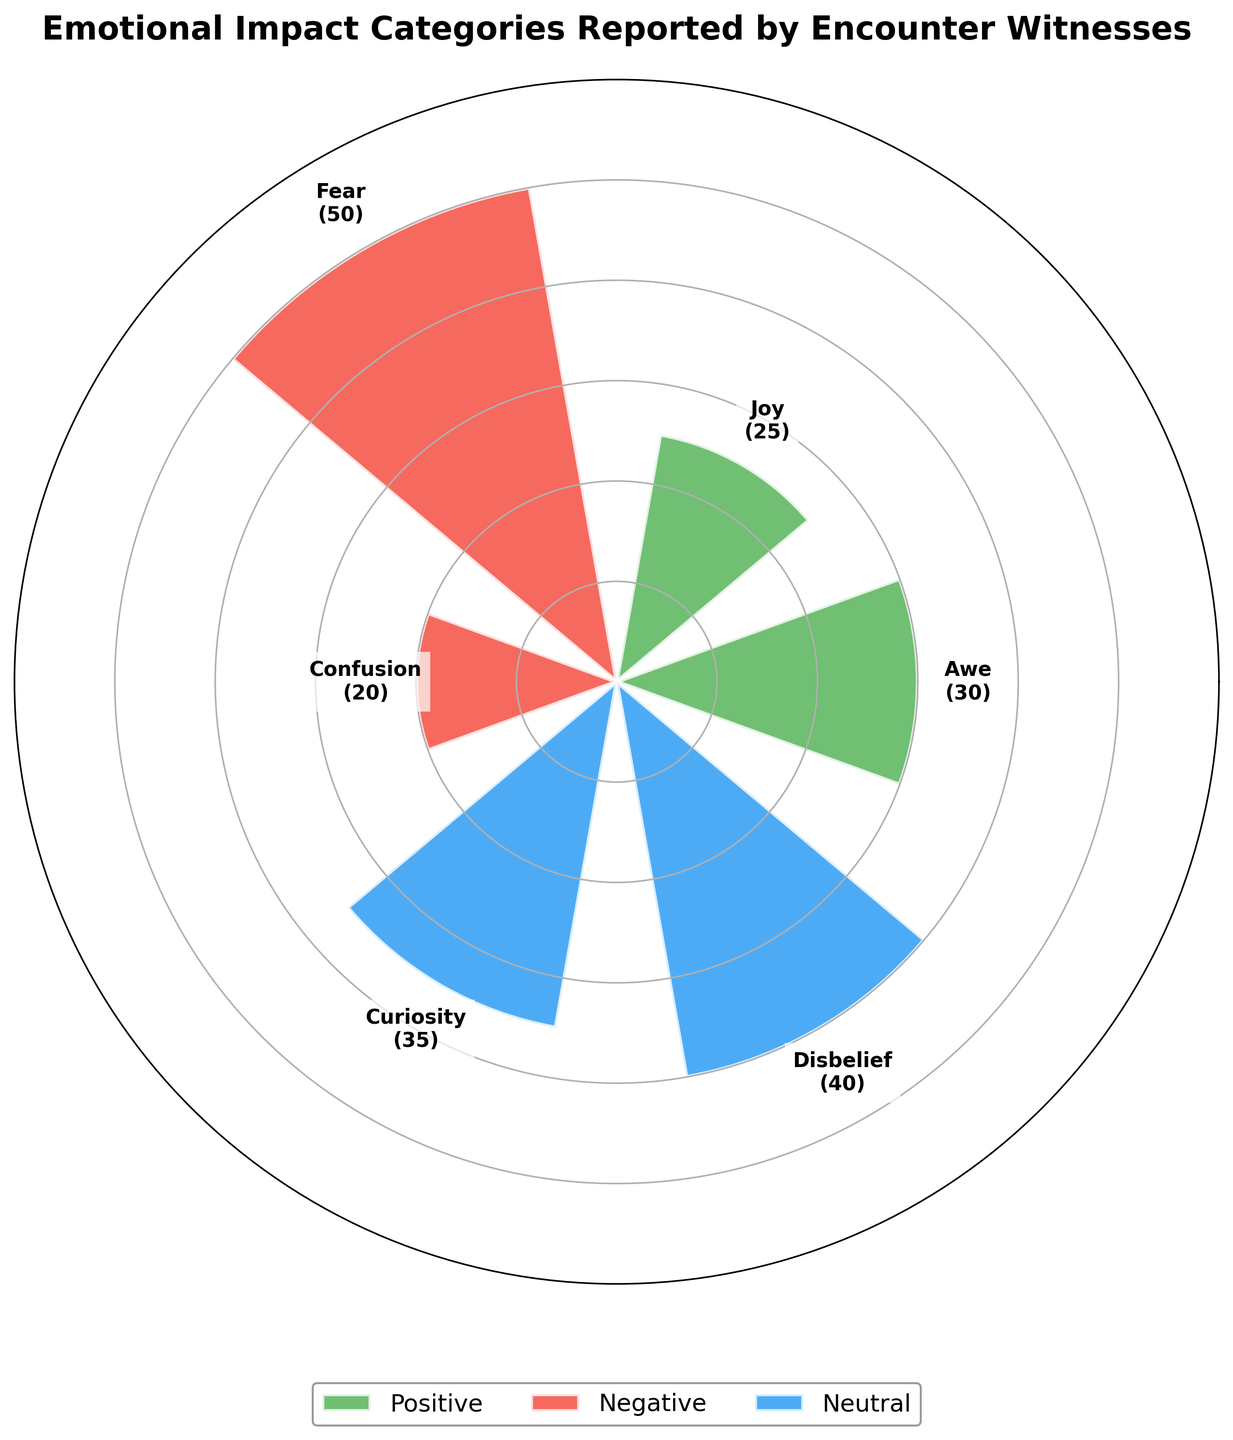What's the title of the chart? The title of the chart is usually the most prominent text and positioned at the top of the figure. In this chart, it reads "Emotional Impact Categories Reported by Encounter Witnesses".
Answer: Emotional Impact Categories Reported by Encounter Witnesses What are the three categories shown in the chart? The chart uses three distinct colors to denote three different categories, which are labeled in the legend at the bottom of the chart. They are Positive, Negative, and Neutral.
Answer: Positive, Negative, Neutral Which emotion has the highest count in the "Neutral" category? Looking at the bar segments labeled under "Neutral", the emotion "Disbelief" has a count of 40, which is higher than "Curiosity" with a count of 35.
Answer: Disbelief How does the count of "Fear" compare to "Joy"? The "Fear" bar segment under the "Negative" category has a count of 50, while the "Joy" bar segment under the "Positive" category has a count of 25. Therefore, "Fear" is greater than "Joy".
Answer: Fear is greater than Joy What is the combined count of the positive emotions? Identify the counts of "Awe" and "Joy" in the "Positive" category, which are 30 and 25 respectively. Add these counts together to get the total. 30 + 25 = 55.
Answer: 55 Which emotion in the "Negative" category has the smallest count? Under the "Negative" category, "Fear" has a count of 50 and "Confusion" has a count of 20. "Confusion" has the smallest count.
Answer: Confusion Are there more positive or neutral emotions reported? Compare the total counts of the "Positive" and "Neutral" categories. The Positive has 55 (Awe + Joy = 30 + 25), and Neutral has 75 (Curiosity + Disbelief = 35 + 40). There are more neutral emotions reported.
Answer: Neutral What's the total number of reported emotions across all categories? Sum the counts of all segments. Positive: 30 (Awe) + 25 (Joy) = 55. Negative: 50 (Fear) + 20 (Confusion) = 70. Neutral: 35 (Curiosity) + 40 (Disbelief) = 75. The total is 55 + 70 + 75 = 200.
Answer: 200 Which category has the largest number of reported emotions? Compare the sum counts of each category: Positive (55), Negative (70), and Neutral (75). Neutral has the largest number of reported emotions.
Answer: Neutral 